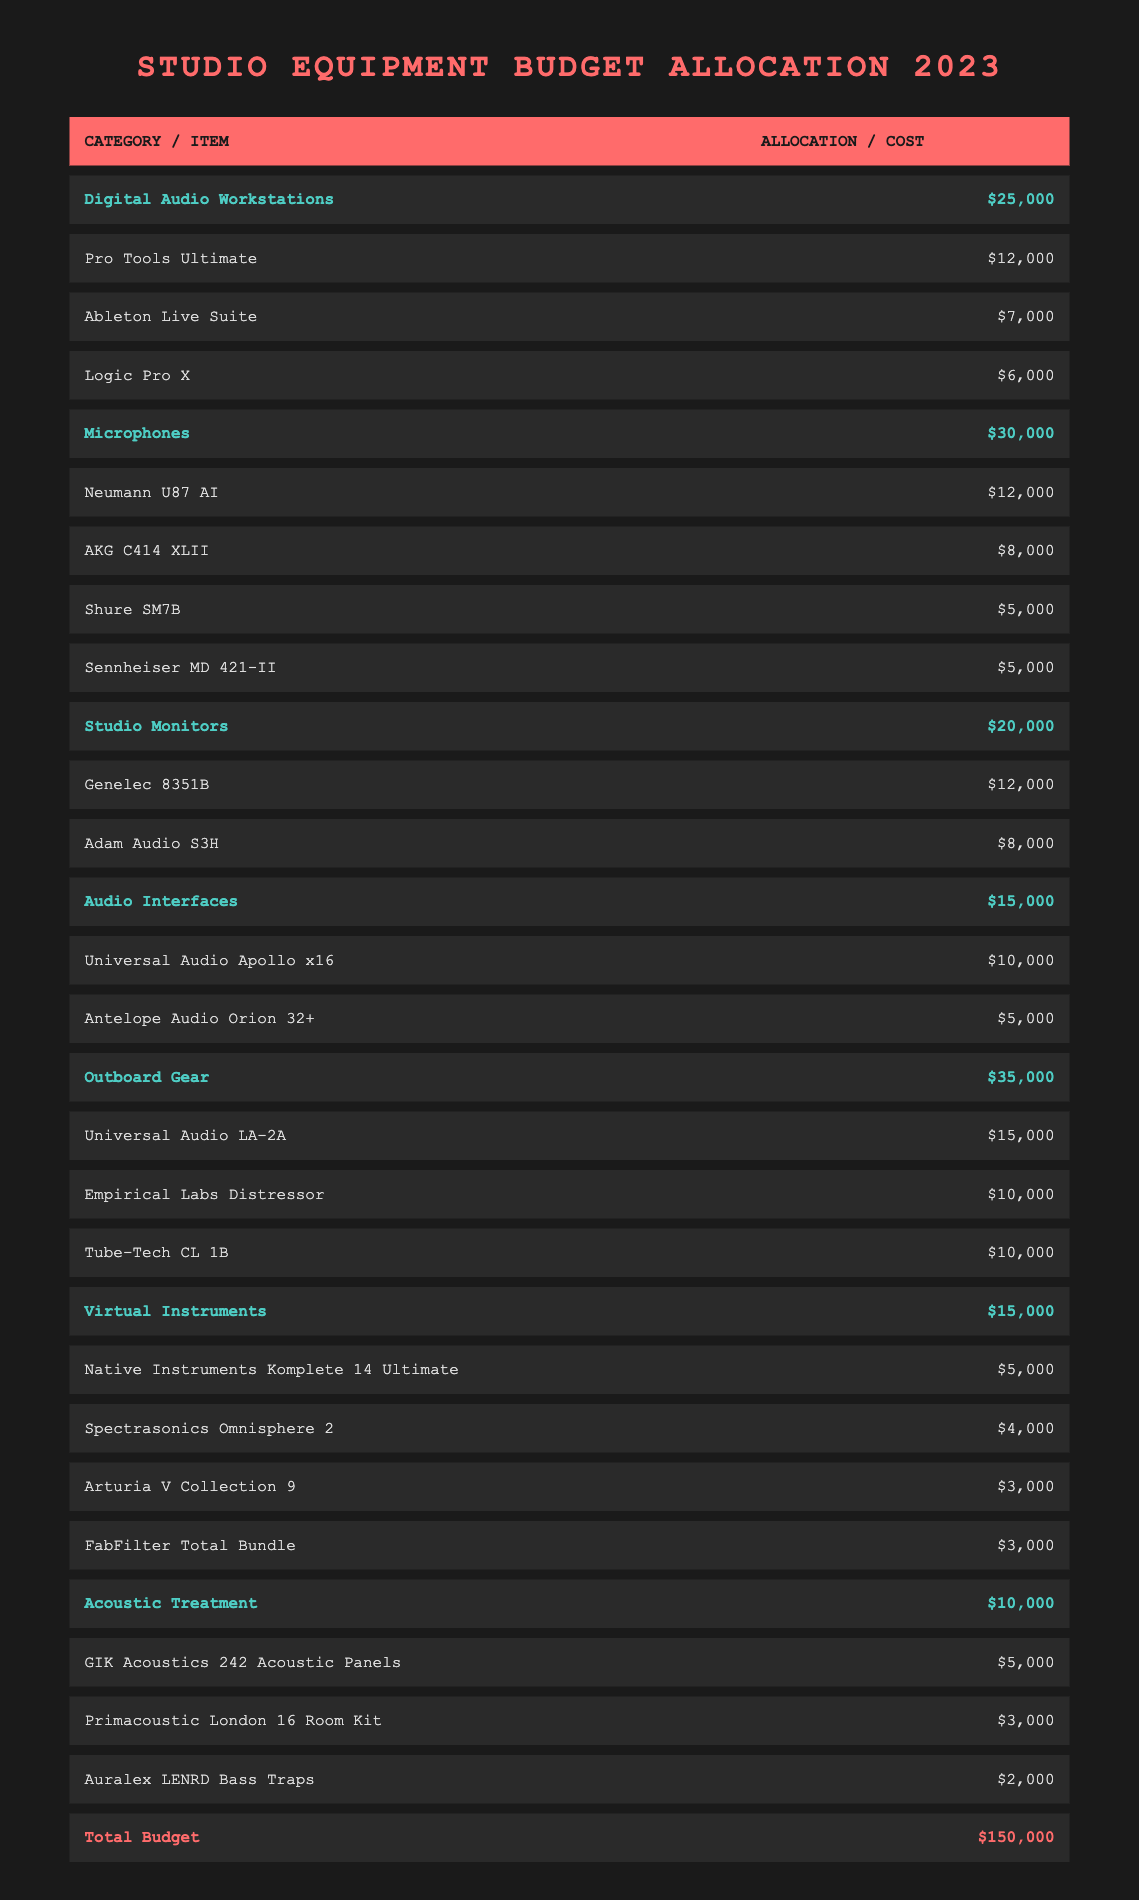What is the total budget allocation for microphones? The budget allocation for microphones is specified directly in the table under the 'Microphones' category, which shows an allocation of $30,000.
Answer: $30,000 What is the cost of the most expensive virtual instrument? The virtual instrument category's items are listed with their costs; the highest cost item is 'Native Instruments Komplete 14 Ultimate' at $5,000.
Answer: $5,000 How much money is allocated to outboard gear compared to studio monitors? The allocation for outboard gear is $35,000, and for studio monitors, it is $20,000. The comparison shows that outboard gear is allocated $15,000 more than studio monitors.
Answer: $15,000 Is the total allocation for digital audio workstations greater than that for acoustic treatment? The total allocation for digital audio workstations is $25,000 and for acoustic treatment, it is $10,000. Since $25,000 is greater than $10,000, the answer is yes.
Answer: Yes What is the combined cost of all microphones? The costs of all microphones listed are Neumann U87 AI ($12,000), AKG C414 XLII ($8,000), Shure SM7B ($5,000), and Sennheiser MD 421-II ($5,000). Summing these costs gives (12,000 + 8,000 + 5,000 + 5,000) = $30,000.
Answer: $30,000 Which category has the lowest allocation and what is the amount? Comparing all allocations, 'Acoustic Treatment' has the lowest allocation of $10,000.
Answer: Acoustic Treatment, $10,000 If I wanted to allocate an additional $2,000 to studio monitors, what would be the new total allocation for that category? The current allocation for studio monitors is $20,000. Adding the additional $2,000 results in a new total allocation of $20,000 + $2,000 = $22,000.
Answer: $22,000 What is the average cost of the items in the outboard gear category? The costs of the items in outboard gear are Universal Audio LA-2A ($15,000), Empirical Labs Distressor ($10,000), and Tube-Tech CL 1B ($10,000). First, sum these costs: (15,000 + 10,000 + 10,000 = 35,000). Then divide by the number of items (3): 35,000 / 3 = $11,667.
Answer: $11,667 How does the allocation for audio interfaces compare with that of virtual instruments? The allocation for audio interfaces is $15,000, while virtual instruments are allocated $15,000 as well. Thus, they have equal allocations.
Answer: Equal 